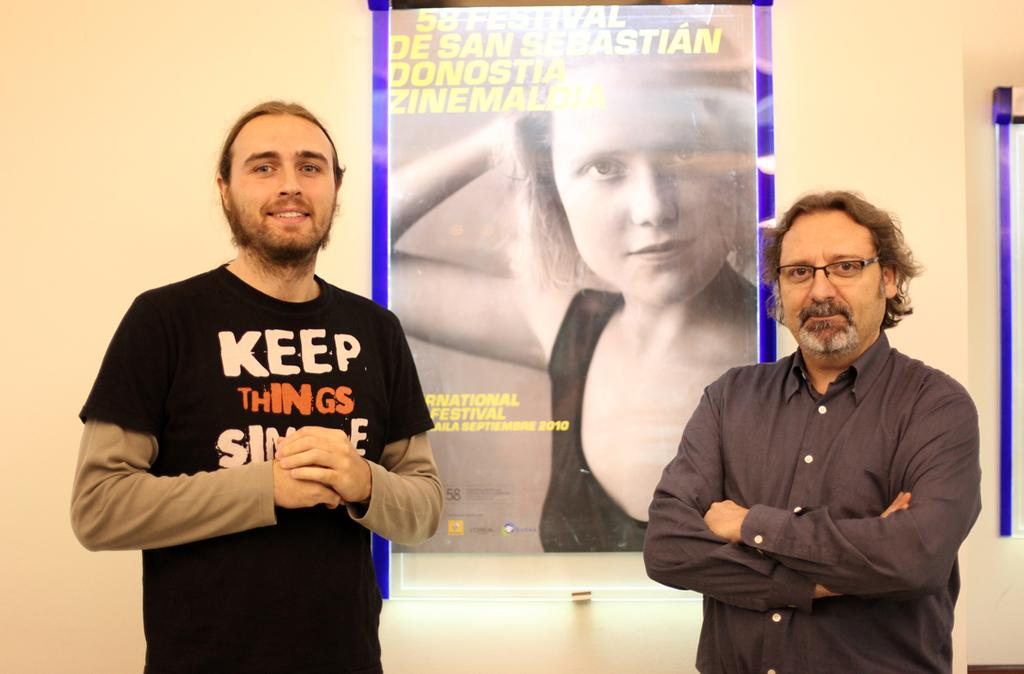What is the position of the man on the left side of the image? There is a man standing on the left side of the image. What color is the clothing worn by the man on the left side? The man on the left side is wearing black. What is the facial expression of the man on the left side? The man on the left side is smiling. What can be seen in the middle of the image? There is a poster of a woman in the middle of the image. What is the man on the right side of the image doing? The man on the right side is standing and holding his hands. Where is the wax sculpture of a desk and drawer located in the image? There is no wax sculpture of a desk and drawer present in the image. 